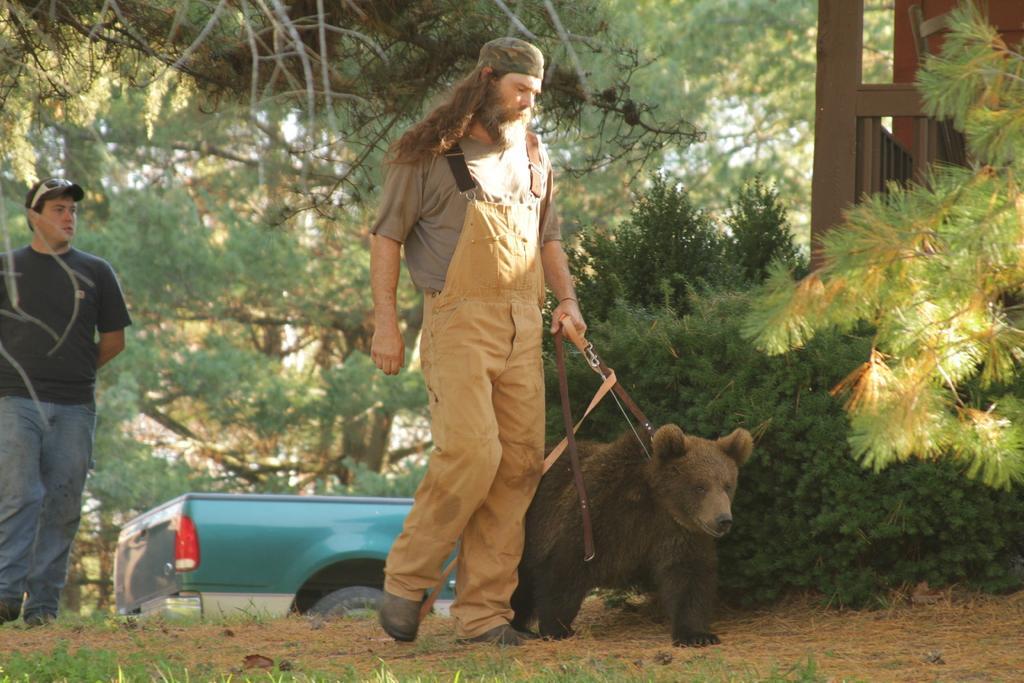In one or two sentences, can you explain what this image depicts? This image is taken outdoors. At the bottom of the image there is a ground with grass on it. In the background there are many trees and plants and a car is parked on the ground. On the left side of the image a man is walking on the ground. In the middle of the image a man is walking on the ground and he is holding a belt, which is kept to the neck of a bear. 